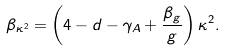Convert formula to latex. <formula><loc_0><loc_0><loc_500><loc_500>\beta _ { \kappa ^ { 2 } } = \left ( 4 - d - \gamma _ { A } + \frac { \beta _ { g } } { g } \right ) \kappa ^ { 2 } .</formula> 